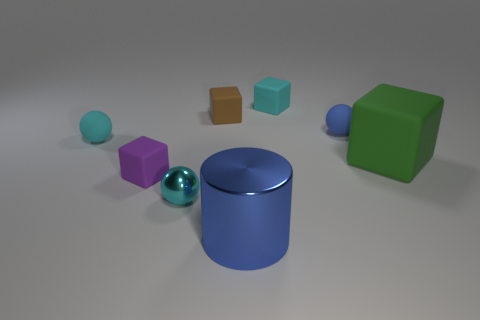Can you describe the lighting in the scene and how it affects the mood or appearance of the objects? The lighting in the scene is soft and diffused, casting gentle shadows and highlighting the form of each object with subtle gradients. This type of lighting tends to create a calm and neutral atmosphere, allowing the viewer to focus on the colors and shapes of the objects without the influence of dramatic shadows or highlights. It enhances the perception of the objects' textures, underscoring their three-dimensional quality. 